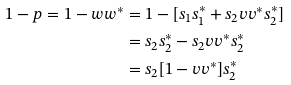Convert formula to latex. <formula><loc_0><loc_0><loc_500><loc_500>1 - p = 1 - w w ^ { * } & = 1 - [ s _ { 1 } s _ { 1 } ^ { * } + s _ { 2 } v v ^ { * } s _ { 2 } ^ { * } ] \\ & = s _ { 2 } s _ { 2 } ^ { * } - s _ { 2 } v v ^ { * } s _ { 2 } ^ { * } \\ & = s _ { 2 } [ 1 - v v ^ { * } ] s _ { 2 } ^ { * }</formula> 